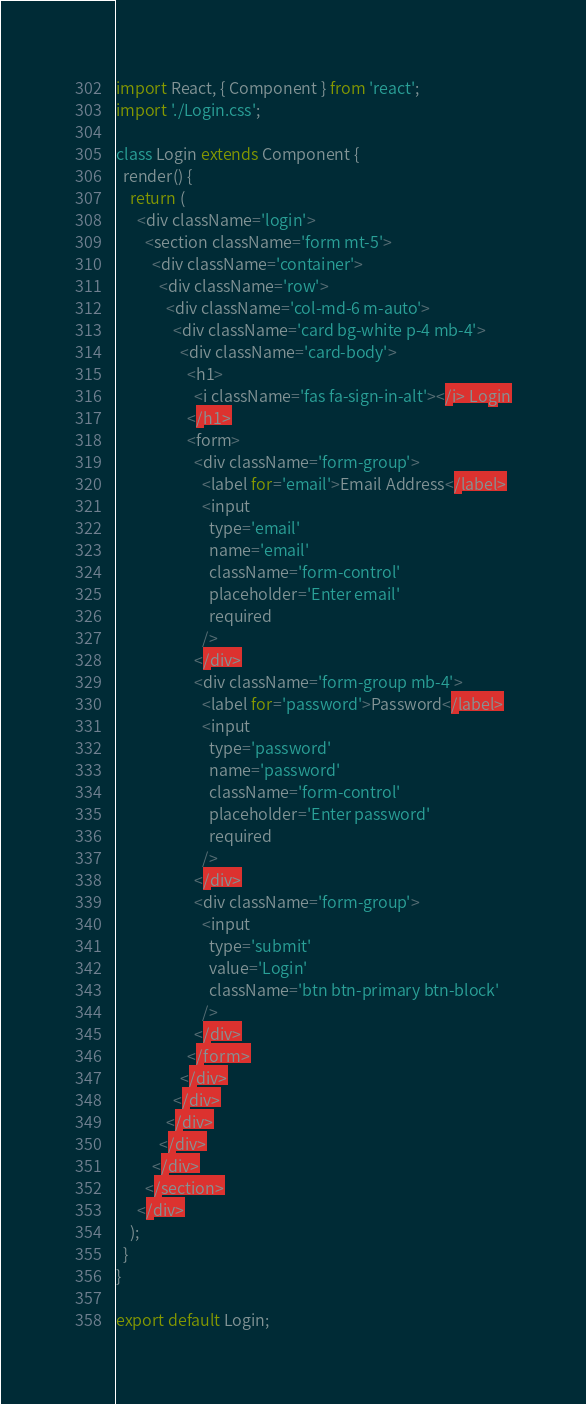<code> <loc_0><loc_0><loc_500><loc_500><_JavaScript_>import React, { Component } from 'react';
import './Login.css';

class Login extends Component {
  render() {
    return (
      <div className='login'>
        <section className='form mt-5'>
          <div className='container'>
            <div className='row'>
              <div className='col-md-6 m-auto'>
                <div className='card bg-white p-4 mb-4'>
                  <div className='card-body'>
                    <h1>
                      <i className='fas fa-sign-in-alt'></i> Login
                    </h1>
                    <form>
                      <div className='form-group'>
                        <label for='email'>Email Address</label>
                        <input
                          type='email'
                          name='email'
                          className='form-control'
                          placeholder='Enter email'
                          required
                        />
                      </div>
                      <div className='form-group mb-4'>
                        <label for='password'>Password</label>
                        <input
                          type='password'
                          name='password'
                          className='form-control'
                          placeholder='Enter password'
                          required
                        />
                      </div>
                      <div className='form-group'>
                        <input
                          type='submit'
                          value='Login'
                          className='btn btn-primary btn-block'
                        />
                      </div>
                    </form>
                  </div>
                </div>
              </div>
            </div>
          </div>
        </section>
      </div>
    );
  }
}

export default Login;
</code> 